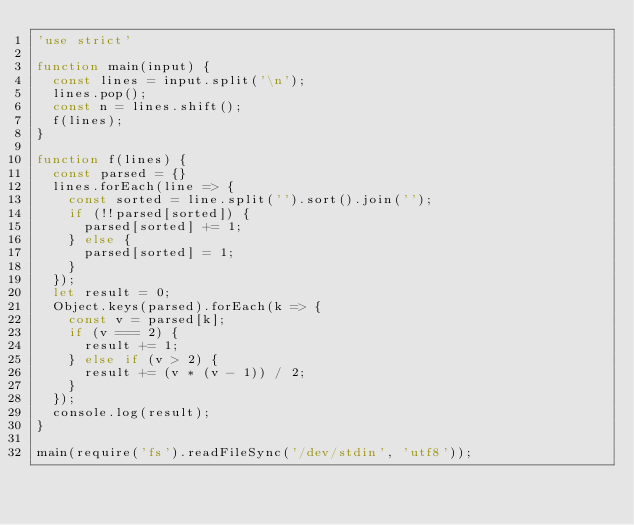Convert code to text. <code><loc_0><loc_0><loc_500><loc_500><_JavaScript_>'use strict'

function main(input) {
  const lines = input.split('\n');
  lines.pop();
  const n = lines.shift();
  f(lines);
}

function f(lines) {
  const parsed = {}
  lines.forEach(line => {
    const sorted = line.split('').sort().join('');
    if (!!parsed[sorted]) {
      parsed[sorted] += 1;
    } else {
      parsed[sorted] = 1;
    }
  });
  let result = 0;
  Object.keys(parsed).forEach(k => {
    const v = parsed[k];
    if (v === 2) {
      result += 1;
    } else if (v > 2) {
      result += (v * (v - 1)) / 2;
    }
  });
  console.log(result);
}

main(require('fs').readFileSync('/dev/stdin', 'utf8'));</code> 